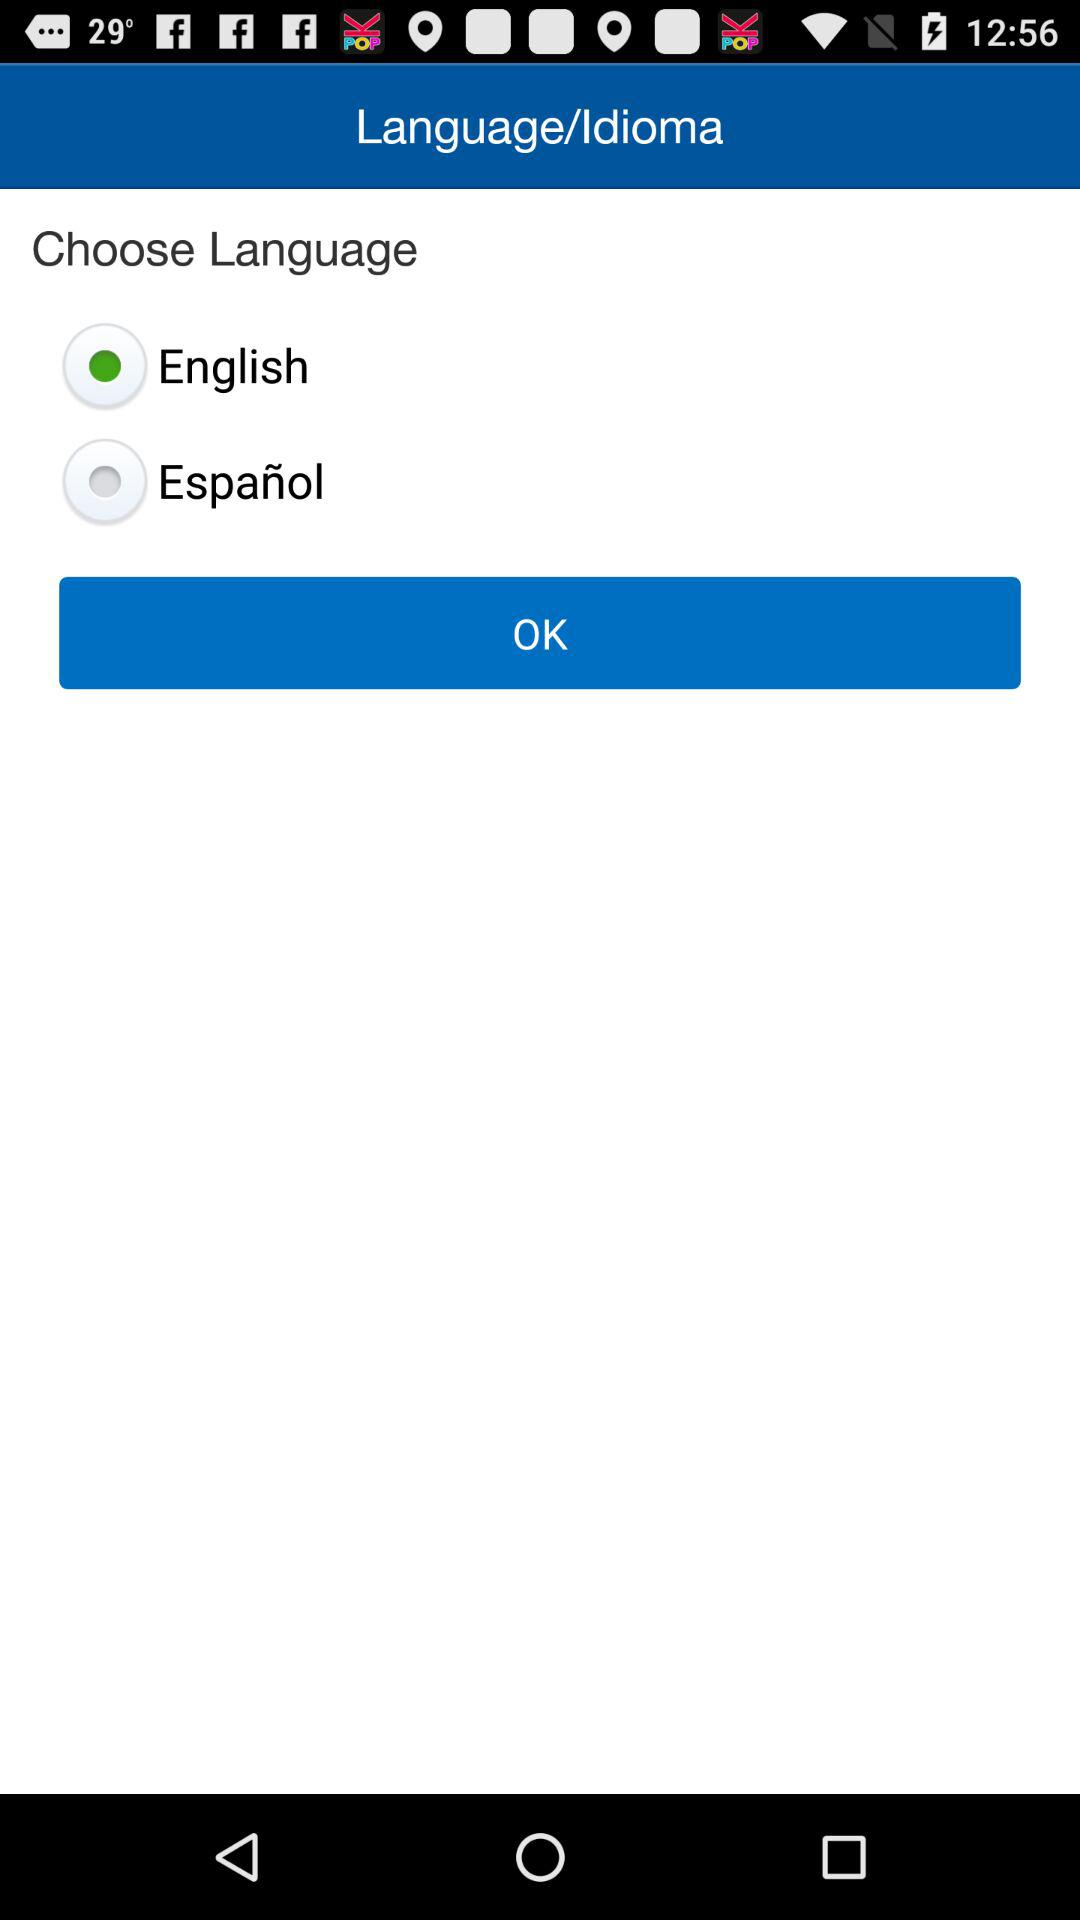What is the selected language? The selected language is English. 